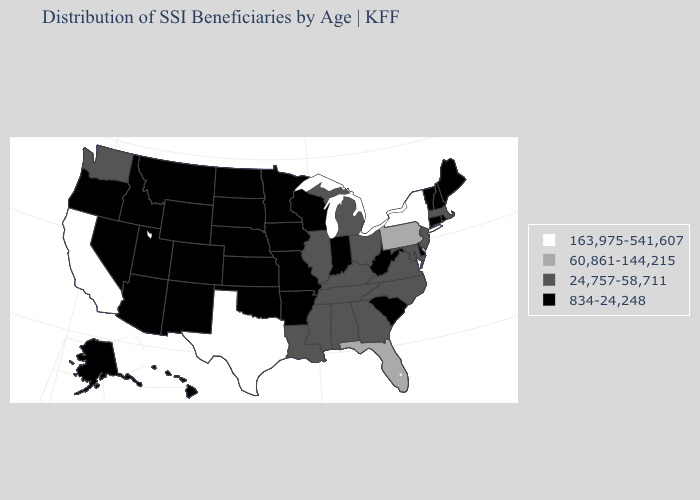What is the value of Washington?
Write a very short answer. 24,757-58,711. Name the states that have a value in the range 163,975-541,607?
Concise answer only. California, New York, Texas. Which states have the lowest value in the USA?
Give a very brief answer. Alaska, Arizona, Arkansas, Colorado, Connecticut, Delaware, Hawaii, Idaho, Indiana, Iowa, Kansas, Maine, Minnesota, Missouri, Montana, Nebraska, Nevada, New Hampshire, New Mexico, North Dakota, Oklahoma, Oregon, Rhode Island, South Carolina, South Dakota, Utah, Vermont, West Virginia, Wisconsin, Wyoming. Does New York have the highest value in the USA?
Answer briefly. Yes. Name the states that have a value in the range 60,861-144,215?
Write a very short answer. Florida, Pennsylvania. Name the states that have a value in the range 163,975-541,607?
Quick response, please. California, New York, Texas. Does Ohio have the highest value in the MidWest?
Answer briefly. Yes. What is the highest value in the USA?
Keep it brief. 163,975-541,607. Which states have the lowest value in the Northeast?
Be succinct. Connecticut, Maine, New Hampshire, Rhode Island, Vermont. Name the states that have a value in the range 24,757-58,711?
Concise answer only. Alabama, Georgia, Illinois, Kentucky, Louisiana, Maryland, Massachusetts, Michigan, Mississippi, New Jersey, North Carolina, Ohio, Tennessee, Virginia, Washington. How many symbols are there in the legend?
Answer briefly. 4. What is the value of Missouri?
Write a very short answer. 834-24,248. Among the states that border Nevada , does Idaho have the highest value?
Concise answer only. No. What is the highest value in the USA?
Quick response, please. 163,975-541,607. Does Nevada have the lowest value in the West?
Concise answer only. Yes. 